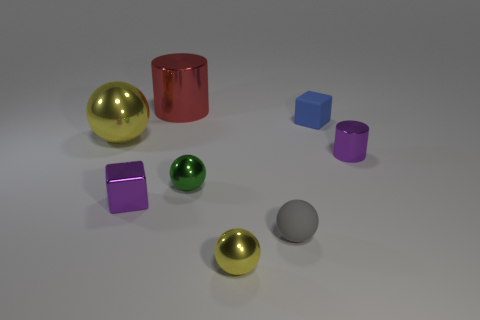Is there a tiny green object?
Give a very brief answer. Yes. Does the tiny block that is left of the rubber block have the same material as the large thing that is behind the big sphere?
Make the answer very short. Yes. There is a tiny thing that is the same color as the tiny metallic cylinder; what shape is it?
Provide a succinct answer. Cube. What number of things are either shiny cylinders that are in front of the blue matte cube or yellow balls behind the small green ball?
Offer a very short reply. 2. Does the large object that is on the left side of the large red metallic object have the same color as the block that is left of the big red cylinder?
Your answer should be compact. No. What shape is the object that is both behind the big yellow shiny sphere and left of the small blue rubber object?
Offer a terse response. Cylinder. The rubber thing that is the same size as the gray rubber sphere is what color?
Offer a very short reply. Blue. Is there a tiny thing that has the same color as the big metallic cylinder?
Your answer should be very brief. No. Do the metal object that is in front of the purple cube and the cylinder left of the tiny blue thing have the same size?
Ensure brevity in your answer.  No. There is a object that is behind the large yellow metal thing and to the right of the large red thing; what material is it?
Provide a succinct answer. Rubber. 